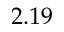<formula> <loc_0><loc_0><loc_500><loc_500>2 . 1 9</formula> 